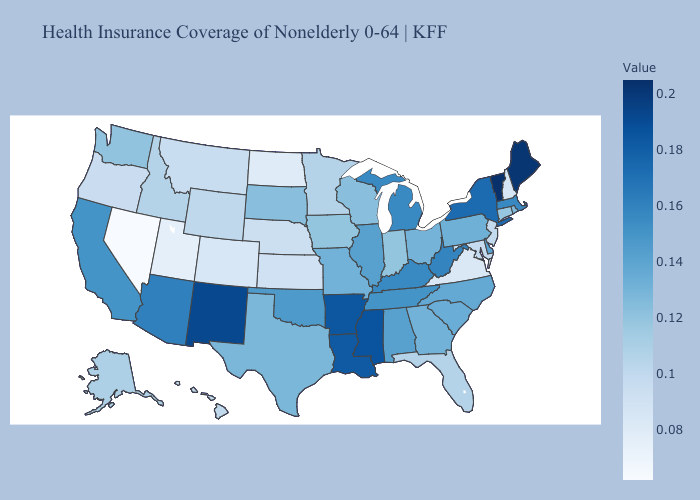Among the states that border California , does Arizona have the lowest value?
Keep it brief. No. Does Iowa have a higher value than West Virginia?
Keep it brief. No. Is the legend a continuous bar?
Give a very brief answer. Yes. Does Connecticut have the highest value in the Northeast?
Write a very short answer. No. Does Nevada have the lowest value in the USA?
Write a very short answer. Yes. Does Alabama have a higher value than West Virginia?
Quick response, please. No. 